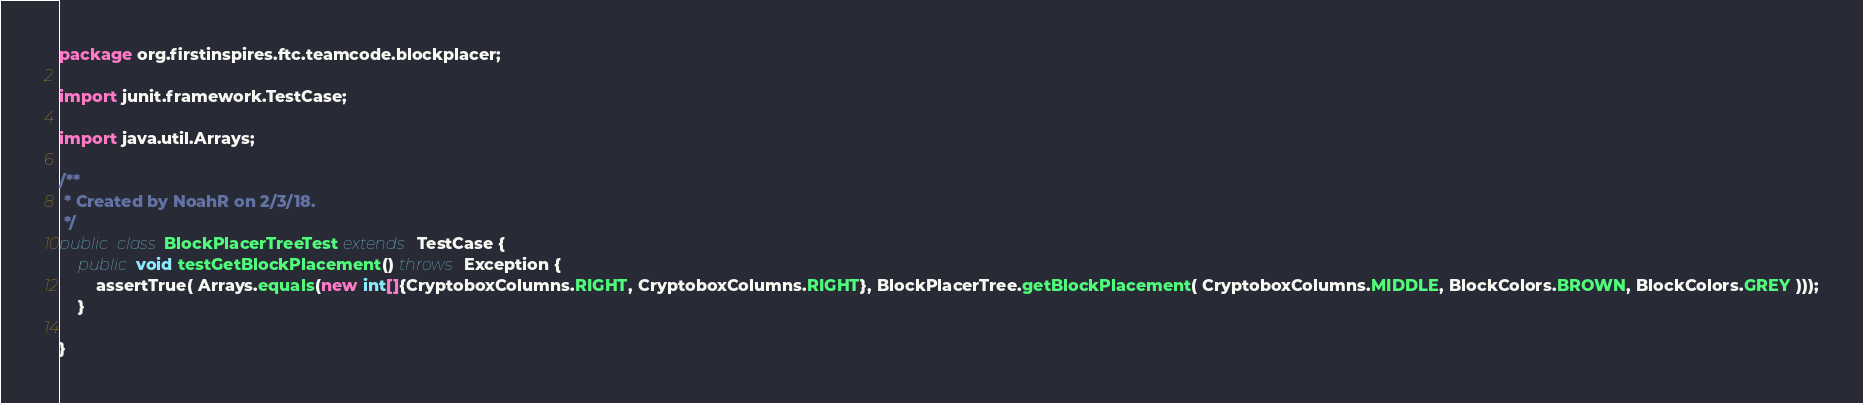<code> <loc_0><loc_0><loc_500><loc_500><_Java_>package org.firstinspires.ftc.teamcode.blockplacer;

import junit.framework.TestCase;

import java.util.Arrays;

/**
 * Created by NoahR on 2/3/18.
 */
public class BlockPlacerTreeTest extends TestCase {
    public void testGetBlockPlacement() throws Exception {
        assertTrue( Arrays.equals(new int[]{CryptoboxColumns.RIGHT, CryptoboxColumns.RIGHT}, BlockPlacerTree.getBlockPlacement( CryptoboxColumns.MIDDLE, BlockColors.BROWN, BlockColors.GREY )));
    }

}</code> 